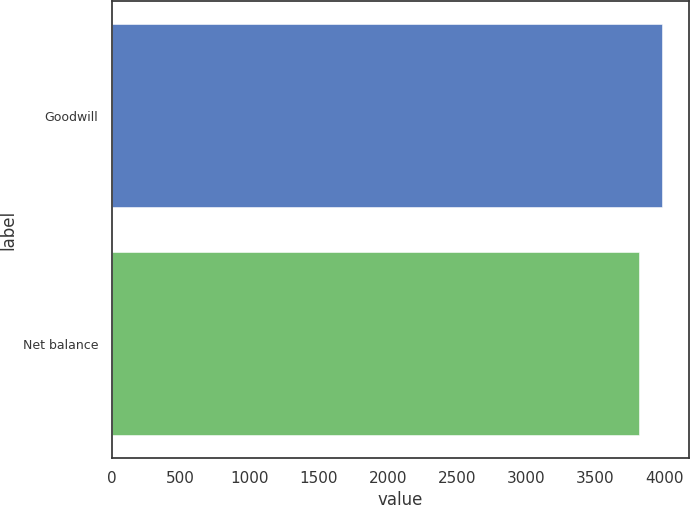Convert chart to OTSL. <chart><loc_0><loc_0><loc_500><loc_500><bar_chart><fcel>Goodwill<fcel>Net balance<nl><fcel>3980<fcel>3820<nl></chart> 